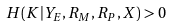<formula> <loc_0><loc_0><loc_500><loc_500>H ( K | Y _ { E } , R _ { M } , R _ { P } , X ) > 0</formula> 